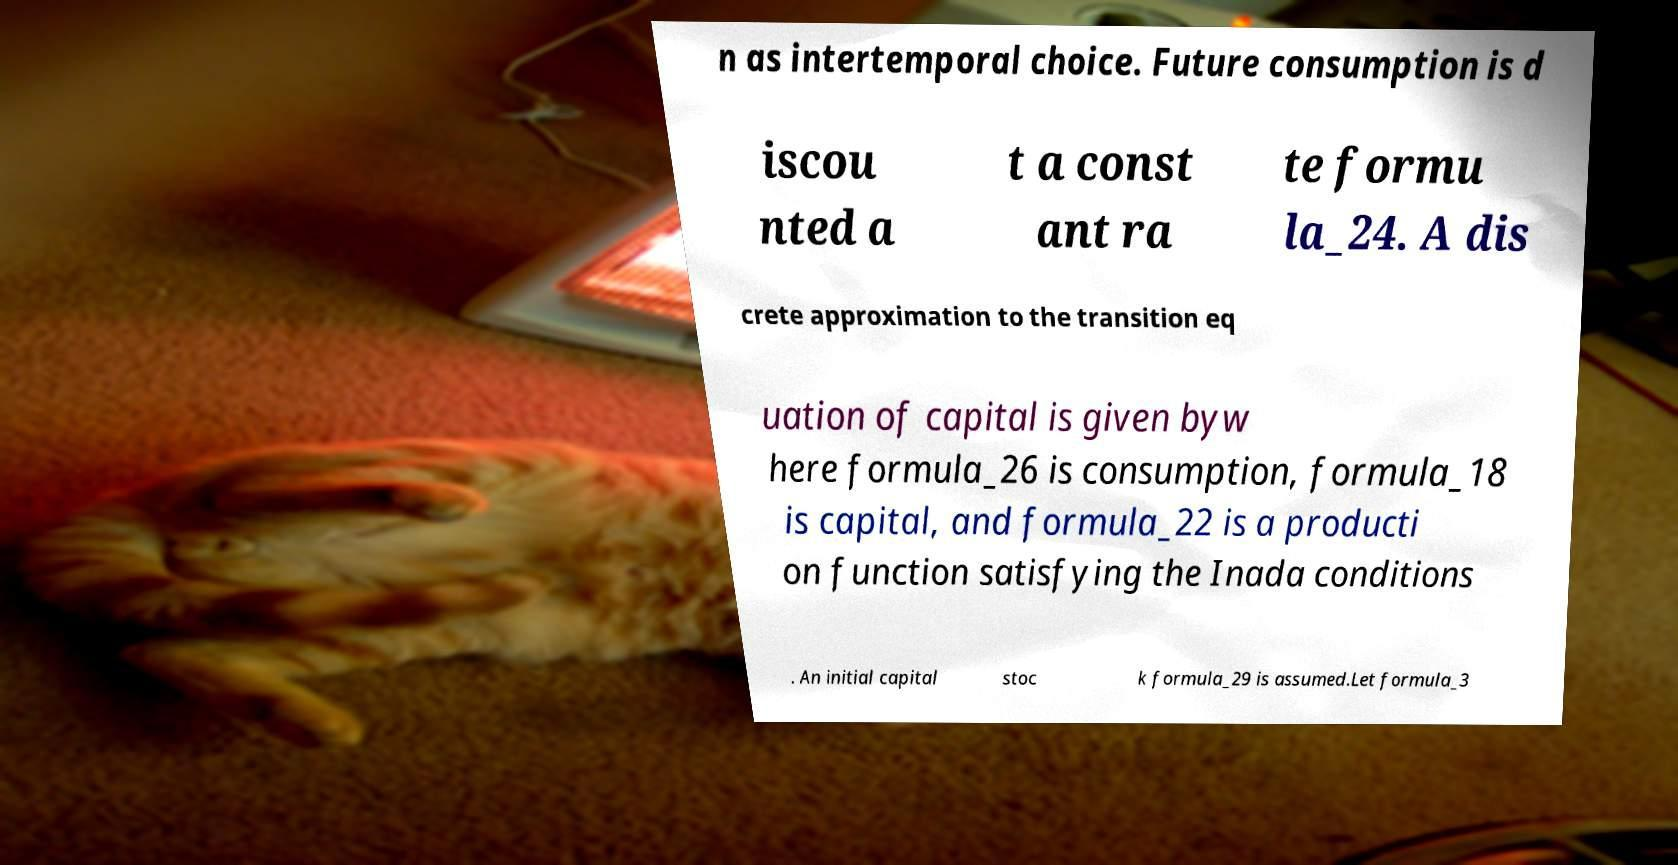I need the written content from this picture converted into text. Can you do that? n as intertemporal choice. Future consumption is d iscou nted a t a const ant ra te formu la_24. A dis crete approximation to the transition eq uation of capital is given byw here formula_26 is consumption, formula_18 is capital, and formula_22 is a producti on function satisfying the Inada conditions . An initial capital stoc k formula_29 is assumed.Let formula_3 